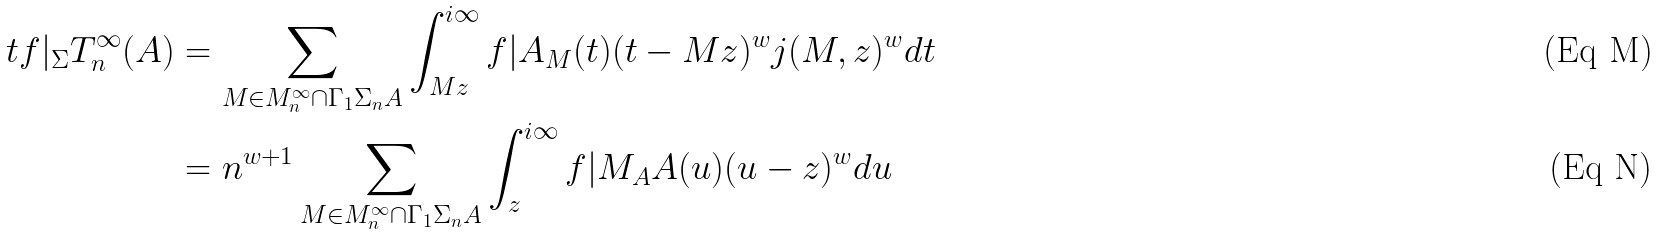Convert formula to latex. <formula><loc_0><loc_0><loc_500><loc_500>\ t f | _ { \Sigma } T _ { n } ^ { \infty } ( A ) & = \sum _ { M \in M _ { n } ^ { \infty } \cap \Gamma _ { 1 } \Sigma _ { n } A } \int _ { M z } ^ { i \infty } f | A _ { M } ( t ) ( t - M z ) ^ { w } j ( M , z ) ^ { w } d t \\ & = n ^ { w + 1 } \sum _ { M \in M _ { n } ^ { \infty } \cap \Gamma _ { 1 } \Sigma _ { n } A } \int _ { z } ^ { i \infty } f | M _ { A } A ( u ) ( u - z ) ^ { w } d u</formula> 